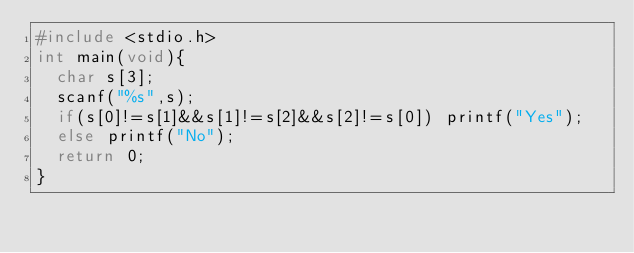<code> <loc_0><loc_0><loc_500><loc_500><_C_>#include <stdio.h>
int main(void){
  char s[3];
  scanf("%s",s);
  if(s[0]!=s[1]&&s[1]!=s[2]&&s[2]!=s[0]) printf("Yes");
  else printf("No");
  return 0;
}</code> 